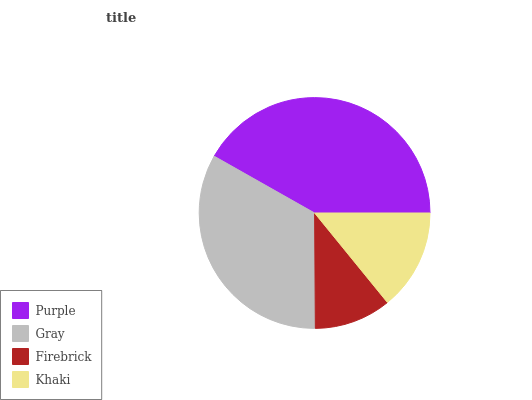Is Firebrick the minimum?
Answer yes or no. Yes. Is Purple the maximum?
Answer yes or no. Yes. Is Gray the minimum?
Answer yes or no. No. Is Gray the maximum?
Answer yes or no. No. Is Purple greater than Gray?
Answer yes or no. Yes. Is Gray less than Purple?
Answer yes or no. Yes. Is Gray greater than Purple?
Answer yes or no. No. Is Purple less than Gray?
Answer yes or no. No. Is Gray the high median?
Answer yes or no. Yes. Is Khaki the low median?
Answer yes or no. Yes. Is Khaki the high median?
Answer yes or no. No. Is Purple the low median?
Answer yes or no. No. 